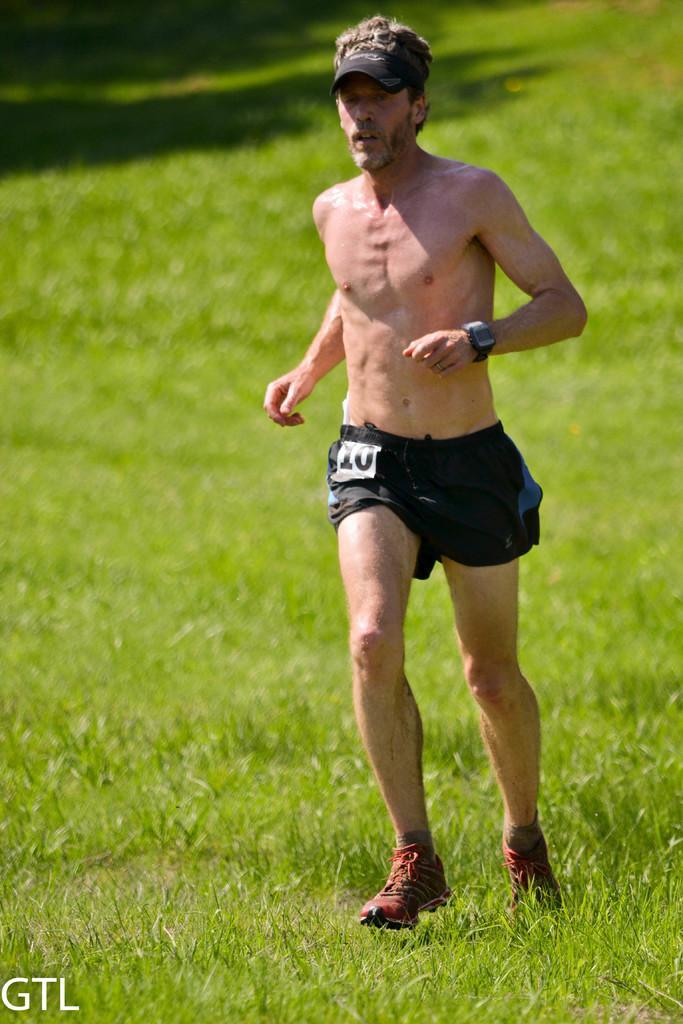Please provide a concise description of this image. In this image, we can see a person is running on the grass. He wore a cap and watch. At the bottom of the image, we can see a watermark. 